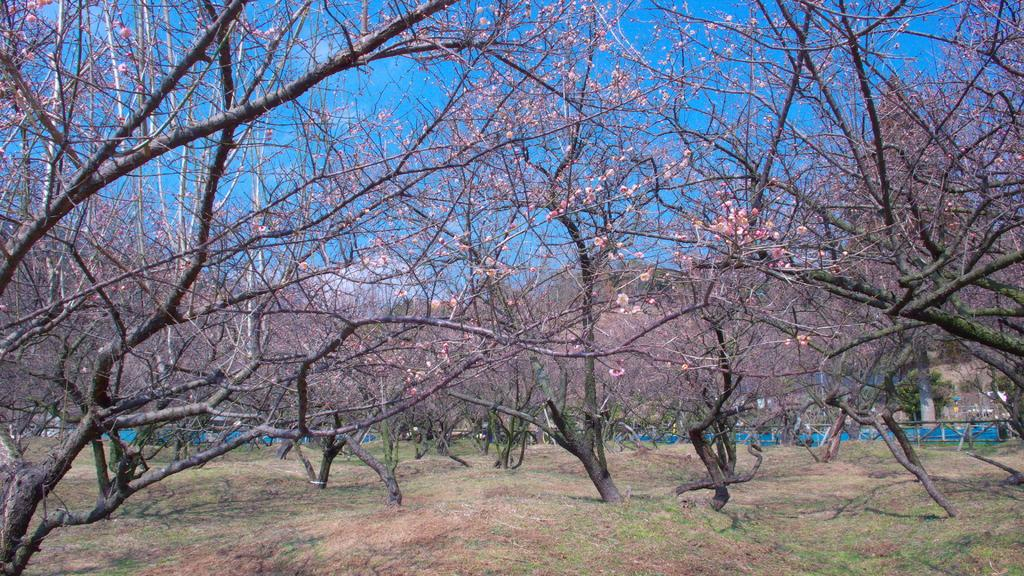What type of vegetation is present in the image? There are trees in the image. What is covering the ground in the image? There is grass on the ground in the image. What can be seen in the background of the image? There is a blue object, a pillar, and a fence in the background of the image. How many chickens are there in the image? There are no chickens present in the image. What is the purpose of the fence in the image? The purpose of the fence cannot be determined from the image alone, as it may serve various purposes such as enclosing an area or providing a boundary. 